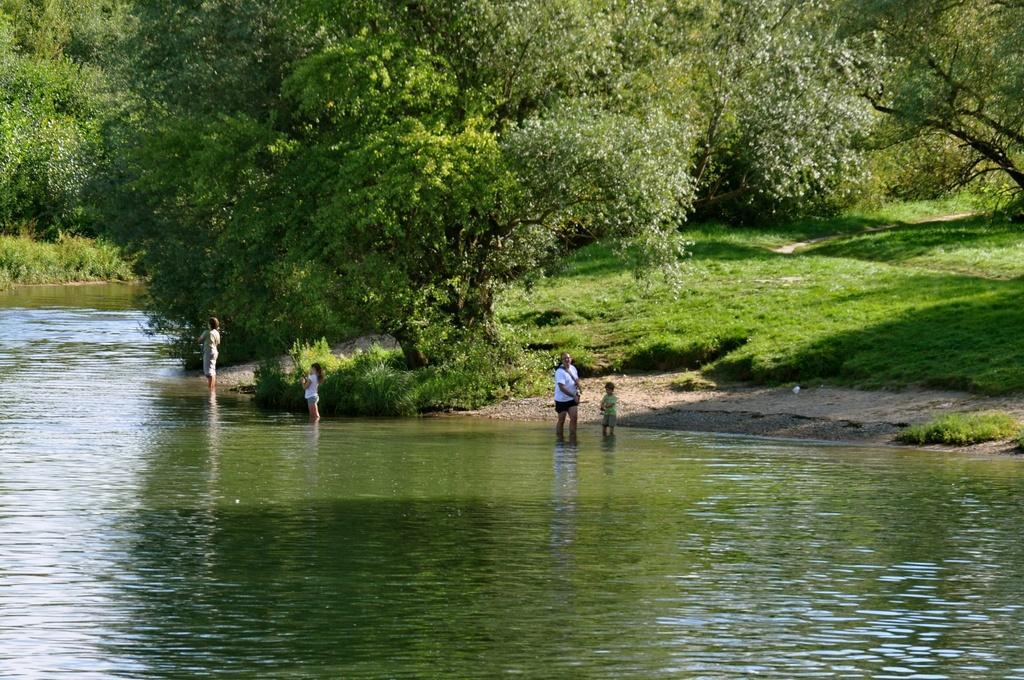Could you give a brief overview of what you see in this image? In this picture I can see few people are standing in the water and I can see trees and grass on the ground. 